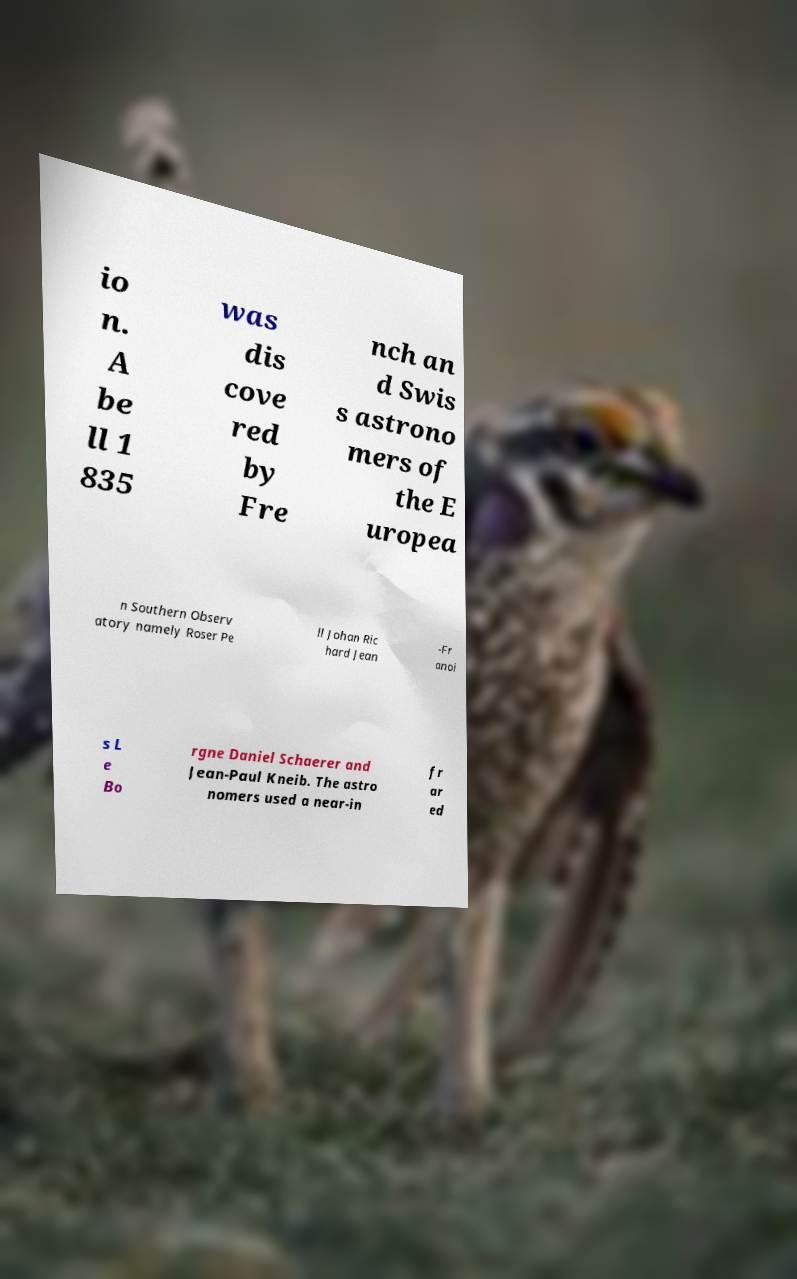Can you accurately transcribe the text from the provided image for me? io n. A be ll 1 835 was dis cove red by Fre nch an d Swis s astrono mers of the E uropea n Southern Observ atory namely Roser Pe ll Johan Ric hard Jean -Fr anoi s L e Bo rgne Daniel Schaerer and Jean-Paul Kneib. The astro nomers used a near-in fr ar ed 